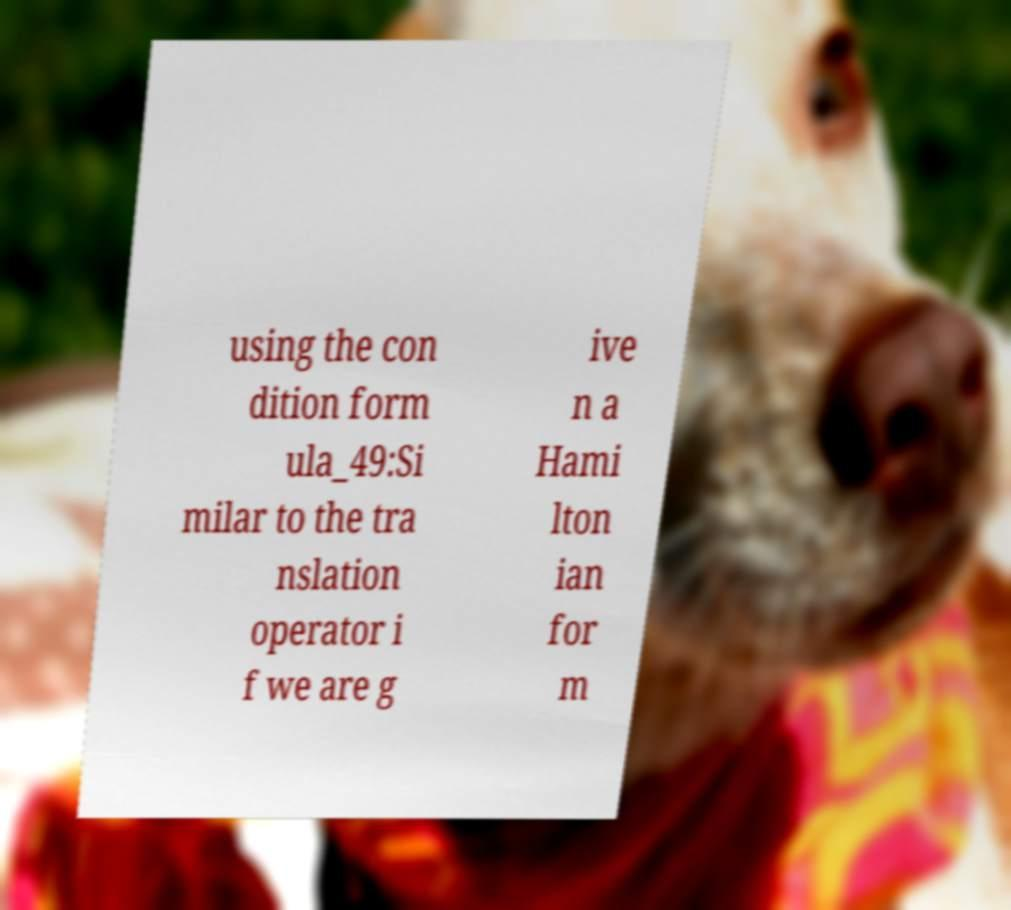Please read and relay the text visible in this image. What does it say? using the con dition form ula_49:Si milar to the tra nslation operator i f we are g ive n a Hami lton ian for m 